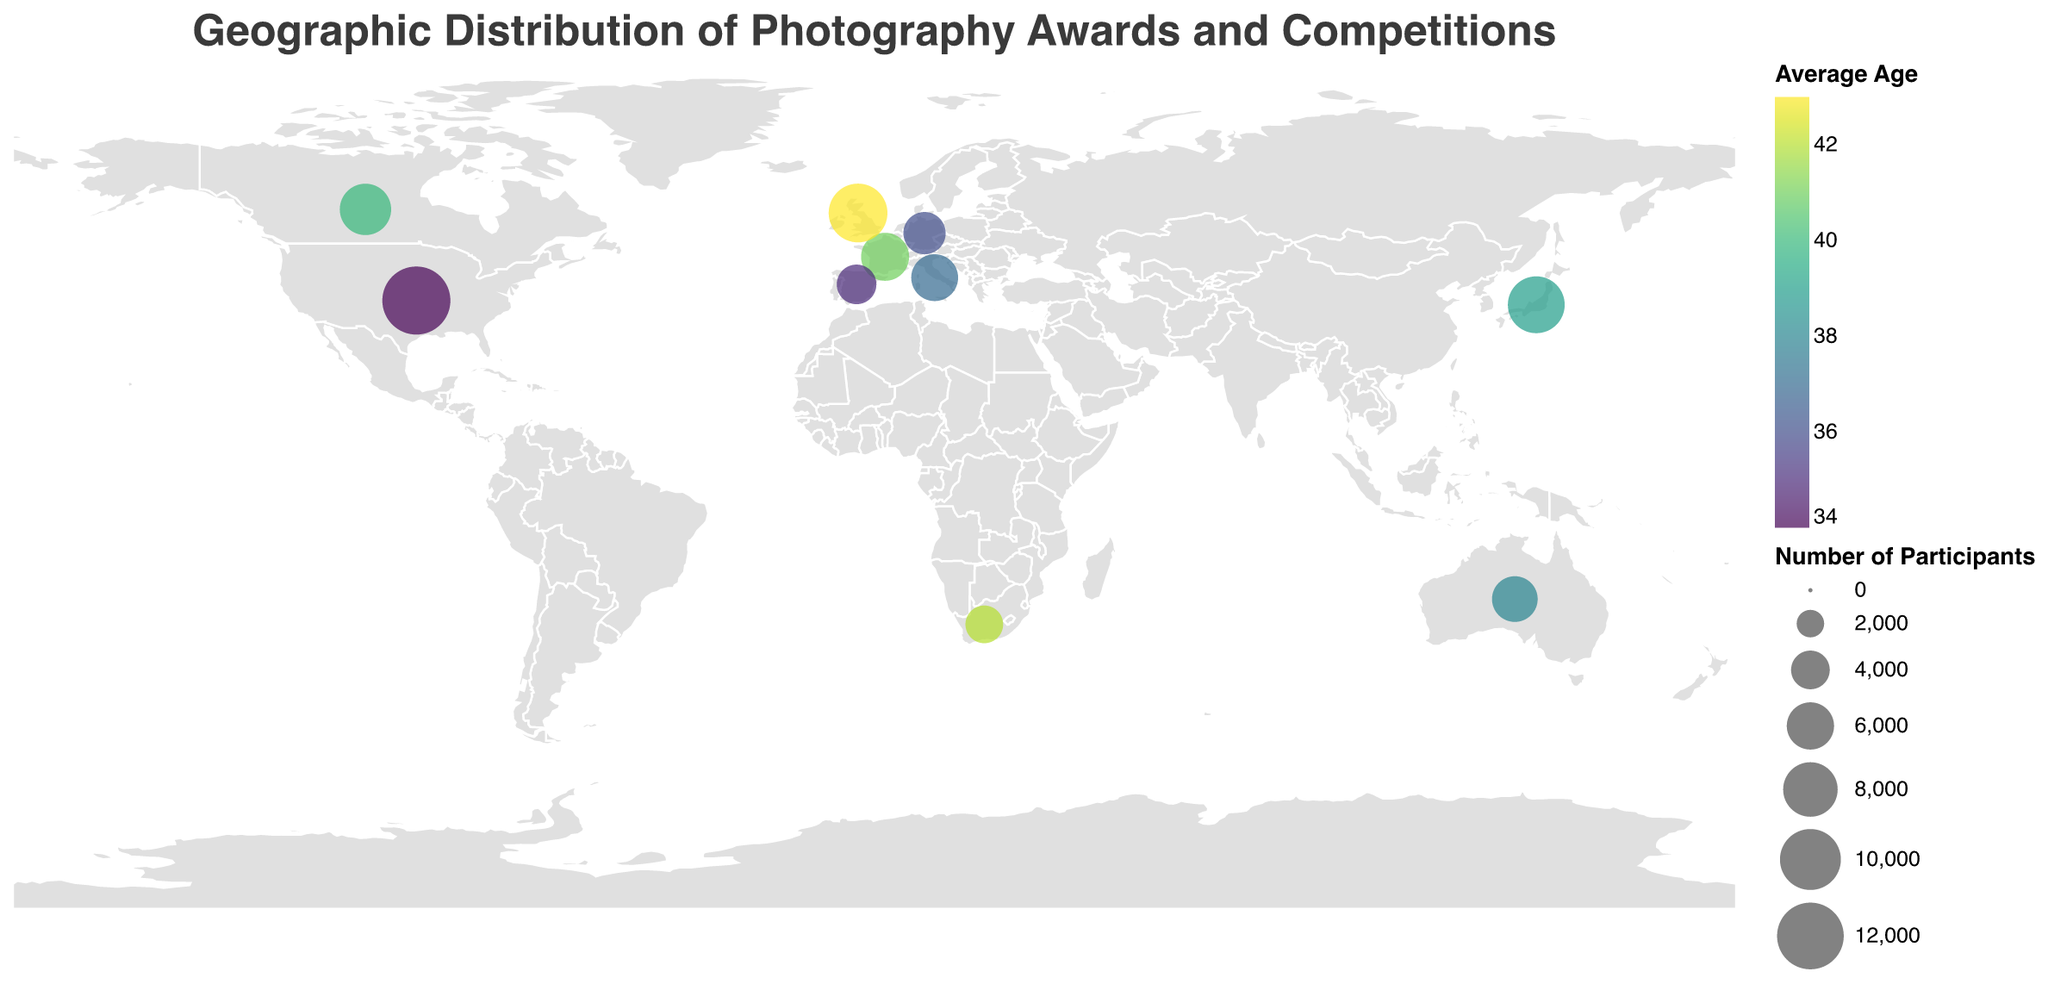How many countries are represented in the plot? The plot visualizes data from different countries. By counting the number of distinct circles on the geographic map, we can determine the number of countries represented.
Answer: 10 Which competition has the highest number of participants, and what is that number? The size of the circles in the plot indicates the number of participants. The largest circle is for the "Sony World Photography Awards" in the United States, which has 12,500 participants.
Answer: Sony World Photography Awards, 12,500 What is the average age of participants in the competitions held in Europe? To find this, we identify the countries in Europe from the plot (France, Germany, United Kingdom, Italy, and Spain), and calculate the average of their participants' average ages: (41 + 36 + 43 + 37 + 35) / 5 = 38.4.
Answer: 38.4 Which country has the youngest average age of participants? By looking at the color gradient in the plot, representing the average age, the lightest color corresponds to the United States with an average age of 34.
Answer: United States What is the difference in the number of participants between the competitions in Japan and South Africa? We subtract the number of participants in South Africa (3,800) from Japan (8,700): 8,700 - 3,800 = 4,900.
Answer: 4,900 Which competition has the most award winners, and how many are there? The plot shows the number of award winners for each competition. The competition with the largest count (indicated by a tooltip) is "Sony World Photography Awards" in the United States with 45 award winners.
Answer: Sony World Photography Awards, 45 Are there more participants in Australia or Canada? The size of the circles indicates the number of participants, with Canada having 7,100 participants and Australia having 5,600. Therefore, Canada has more participants.
Answer: Canada Which country's competition has the oldest average age of participants? Examining the color gradient, the darkest color represents the United Kingdom with an average age of 43.
Answer: United Kingdom What is the total number of participants in competitions held in the Americas? We sum the number of participants in the United States and Canada: 12,500 (US) + 7,100 (Canada) = 19,600.
Answer: 19,600 How many award winners are there in total across all competitions in Europe? Summing the number of award winners in France (25), Germany (20), United Kingdom (35), Italy (24), and Spain (18): 25 + 20 + 35 + 24 + 18 = 122.
Answer: 122 